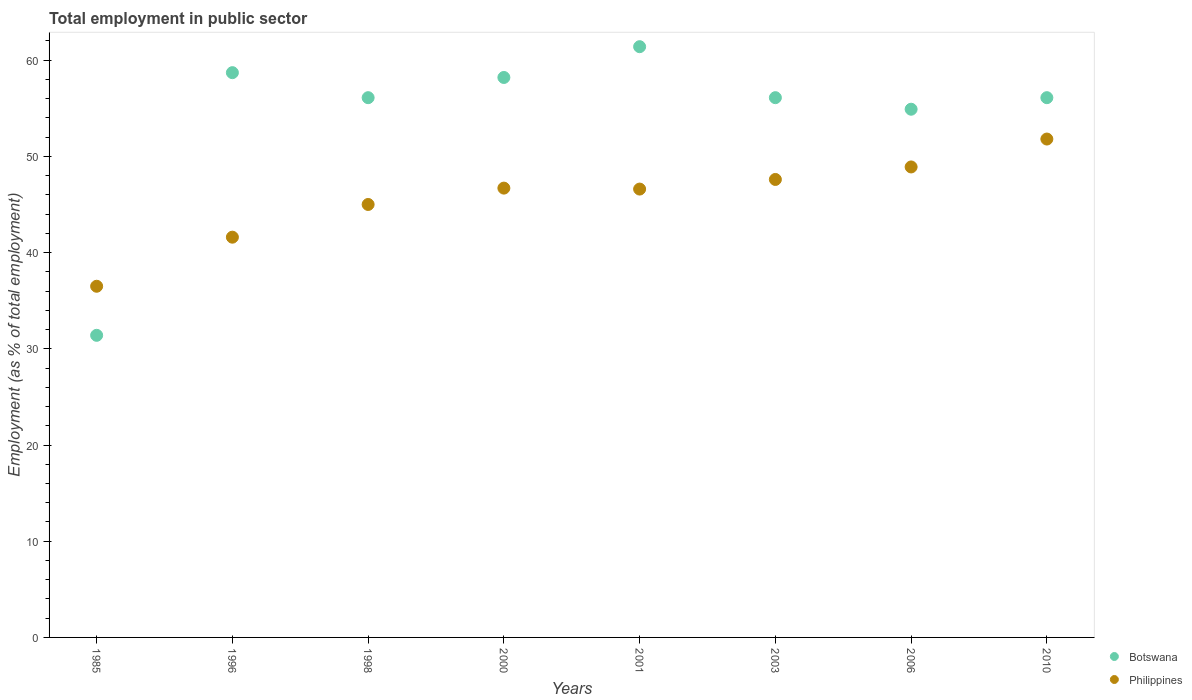Is the number of dotlines equal to the number of legend labels?
Offer a terse response. Yes. What is the employment in public sector in Botswana in 1985?
Keep it short and to the point. 31.4. Across all years, what is the maximum employment in public sector in Botswana?
Offer a very short reply. 61.4. Across all years, what is the minimum employment in public sector in Philippines?
Keep it short and to the point. 36.5. In which year was the employment in public sector in Philippines maximum?
Your answer should be compact. 2010. What is the total employment in public sector in Botswana in the graph?
Offer a very short reply. 432.9. What is the difference between the employment in public sector in Philippines in 2003 and that in 2010?
Keep it short and to the point. -4.2. What is the difference between the employment in public sector in Philippines in 1985 and the employment in public sector in Botswana in 2001?
Your answer should be very brief. -24.9. What is the average employment in public sector in Philippines per year?
Ensure brevity in your answer.  45.59. In the year 1985, what is the difference between the employment in public sector in Philippines and employment in public sector in Botswana?
Offer a terse response. 5.1. In how many years, is the employment in public sector in Botswana greater than 34 %?
Ensure brevity in your answer.  7. What is the ratio of the employment in public sector in Botswana in 1985 to that in 1996?
Offer a terse response. 0.53. Is the employment in public sector in Botswana in 1985 less than that in 2010?
Provide a short and direct response. Yes. Is the difference between the employment in public sector in Philippines in 1998 and 2010 greater than the difference between the employment in public sector in Botswana in 1998 and 2010?
Your response must be concise. No. What is the difference between the highest and the second highest employment in public sector in Philippines?
Your answer should be very brief. 2.9. What is the difference between the highest and the lowest employment in public sector in Botswana?
Provide a short and direct response. 30. Is the sum of the employment in public sector in Botswana in 1996 and 2010 greater than the maximum employment in public sector in Philippines across all years?
Give a very brief answer. Yes. Is the employment in public sector in Philippines strictly greater than the employment in public sector in Botswana over the years?
Provide a succinct answer. No. Is the employment in public sector in Philippines strictly less than the employment in public sector in Botswana over the years?
Make the answer very short. No. Does the graph contain grids?
Give a very brief answer. No. Where does the legend appear in the graph?
Your response must be concise. Bottom right. How many legend labels are there?
Provide a short and direct response. 2. What is the title of the graph?
Ensure brevity in your answer.  Total employment in public sector. What is the label or title of the Y-axis?
Make the answer very short. Employment (as % of total employment). What is the Employment (as % of total employment) in Botswana in 1985?
Your response must be concise. 31.4. What is the Employment (as % of total employment) in Philippines in 1985?
Provide a succinct answer. 36.5. What is the Employment (as % of total employment) of Botswana in 1996?
Your answer should be compact. 58.7. What is the Employment (as % of total employment) in Philippines in 1996?
Provide a succinct answer. 41.6. What is the Employment (as % of total employment) of Botswana in 1998?
Your response must be concise. 56.1. What is the Employment (as % of total employment) of Philippines in 1998?
Offer a terse response. 45. What is the Employment (as % of total employment) of Botswana in 2000?
Your response must be concise. 58.2. What is the Employment (as % of total employment) in Philippines in 2000?
Your answer should be compact. 46.7. What is the Employment (as % of total employment) of Botswana in 2001?
Your answer should be compact. 61.4. What is the Employment (as % of total employment) in Philippines in 2001?
Keep it short and to the point. 46.6. What is the Employment (as % of total employment) of Botswana in 2003?
Provide a succinct answer. 56.1. What is the Employment (as % of total employment) in Philippines in 2003?
Your answer should be compact. 47.6. What is the Employment (as % of total employment) of Botswana in 2006?
Provide a succinct answer. 54.9. What is the Employment (as % of total employment) of Philippines in 2006?
Your response must be concise. 48.9. What is the Employment (as % of total employment) of Botswana in 2010?
Your response must be concise. 56.1. What is the Employment (as % of total employment) in Philippines in 2010?
Keep it short and to the point. 51.8. Across all years, what is the maximum Employment (as % of total employment) of Botswana?
Make the answer very short. 61.4. Across all years, what is the maximum Employment (as % of total employment) in Philippines?
Offer a terse response. 51.8. Across all years, what is the minimum Employment (as % of total employment) of Botswana?
Keep it short and to the point. 31.4. Across all years, what is the minimum Employment (as % of total employment) of Philippines?
Ensure brevity in your answer.  36.5. What is the total Employment (as % of total employment) of Botswana in the graph?
Make the answer very short. 432.9. What is the total Employment (as % of total employment) in Philippines in the graph?
Offer a terse response. 364.7. What is the difference between the Employment (as % of total employment) of Botswana in 1985 and that in 1996?
Ensure brevity in your answer.  -27.3. What is the difference between the Employment (as % of total employment) of Botswana in 1985 and that in 1998?
Offer a very short reply. -24.7. What is the difference between the Employment (as % of total employment) in Philippines in 1985 and that in 1998?
Provide a short and direct response. -8.5. What is the difference between the Employment (as % of total employment) in Botswana in 1985 and that in 2000?
Offer a terse response. -26.8. What is the difference between the Employment (as % of total employment) in Philippines in 1985 and that in 2000?
Your response must be concise. -10.2. What is the difference between the Employment (as % of total employment) of Botswana in 1985 and that in 2003?
Your response must be concise. -24.7. What is the difference between the Employment (as % of total employment) of Philippines in 1985 and that in 2003?
Keep it short and to the point. -11.1. What is the difference between the Employment (as % of total employment) in Botswana in 1985 and that in 2006?
Make the answer very short. -23.5. What is the difference between the Employment (as % of total employment) of Botswana in 1985 and that in 2010?
Keep it short and to the point. -24.7. What is the difference between the Employment (as % of total employment) of Philippines in 1985 and that in 2010?
Provide a short and direct response. -15.3. What is the difference between the Employment (as % of total employment) of Botswana in 1996 and that in 1998?
Your answer should be very brief. 2.6. What is the difference between the Employment (as % of total employment) of Philippines in 1996 and that in 2000?
Your answer should be very brief. -5.1. What is the difference between the Employment (as % of total employment) in Philippines in 1996 and that in 2006?
Offer a terse response. -7.3. What is the difference between the Employment (as % of total employment) of Philippines in 1996 and that in 2010?
Ensure brevity in your answer.  -10.2. What is the difference between the Employment (as % of total employment) in Botswana in 1998 and that in 2000?
Ensure brevity in your answer.  -2.1. What is the difference between the Employment (as % of total employment) in Philippines in 1998 and that in 2000?
Your response must be concise. -1.7. What is the difference between the Employment (as % of total employment) in Philippines in 1998 and that in 2001?
Provide a short and direct response. -1.6. What is the difference between the Employment (as % of total employment) of Philippines in 1998 and that in 2003?
Your response must be concise. -2.6. What is the difference between the Employment (as % of total employment) in Botswana in 1998 and that in 2006?
Provide a succinct answer. 1.2. What is the difference between the Employment (as % of total employment) of Philippines in 1998 and that in 2006?
Your response must be concise. -3.9. What is the difference between the Employment (as % of total employment) in Philippines in 1998 and that in 2010?
Ensure brevity in your answer.  -6.8. What is the difference between the Employment (as % of total employment) of Botswana in 2000 and that in 2001?
Provide a succinct answer. -3.2. What is the difference between the Employment (as % of total employment) in Philippines in 2000 and that in 2001?
Keep it short and to the point. 0.1. What is the difference between the Employment (as % of total employment) of Botswana in 2000 and that in 2003?
Your answer should be very brief. 2.1. What is the difference between the Employment (as % of total employment) of Botswana in 2000 and that in 2010?
Offer a very short reply. 2.1. What is the difference between the Employment (as % of total employment) in Philippines in 2000 and that in 2010?
Give a very brief answer. -5.1. What is the difference between the Employment (as % of total employment) in Botswana in 2001 and that in 2003?
Provide a succinct answer. 5.3. What is the difference between the Employment (as % of total employment) of Philippines in 2001 and that in 2006?
Offer a terse response. -2.3. What is the difference between the Employment (as % of total employment) of Philippines in 2003 and that in 2006?
Your answer should be very brief. -1.3. What is the difference between the Employment (as % of total employment) of Botswana in 2006 and that in 2010?
Offer a very short reply. -1.2. What is the difference between the Employment (as % of total employment) in Botswana in 1985 and the Employment (as % of total employment) in Philippines in 2000?
Ensure brevity in your answer.  -15.3. What is the difference between the Employment (as % of total employment) of Botswana in 1985 and the Employment (as % of total employment) of Philippines in 2001?
Your answer should be compact. -15.2. What is the difference between the Employment (as % of total employment) in Botswana in 1985 and the Employment (as % of total employment) in Philippines in 2003?
Offer a very short reply. -16.2. What is the difference between the Employment (as % of total employment) of Botswana in 1985 and the Employment (as % of total employment) of Philippines in 2006?
Offer a terse response. -17.5. What is the difference between the Employment (as % of total employment) of Botswana in 1985 and the Employment (as % of total employment) of Philippines in 2010?
Make the answer very short. -20.4. What is the difference between the Employment (as % of total employment) in Botswana in 1996 and the Employment (as % of total employment) in Philippines in 2000?
Your answer should be compact. 12. What is the difference between the Employment (as % of total employment) in Botswana in 1996 and the Employment (as % of total employment) in Philippines in 2006?
Provide a short and direct response. 9.8. What is the difference between the Employment (as % of total employment) in Botswana in 1998 and the Employment (as % of total employment) in Philippines in 2001?
Offer a very short reply. 9.5. What is the difference between the Employment (as % of total employment) in Botswana in 1998 and the Employment (as % of total employment) in Philippines in 2003?
Make the answer very short. 8.5. What is the difference between the Employment (as % of total employment) in Botswana in 1998 and the Employment (as % of total employment) in Philippines in 2006?
Offer a terse response. 7.2. What is the difference between the Employment (as % of total employment) in Botswana in 2000 and the Employment (as % of total employment) in Philippines in 2006?
Offer a terse response. 9.3. What is the difference between the Employment (as % of total employment) in Botswana in 2000 and the Employment (as % of total employment) in Philippines in 2010?
Make the answer very short. 6.4. What is the difference between the Employment (as % of total employment) in Botswana in 2001 and the Employment (as % of total employment) in Philippines in 2006?
Make the answer very short. 12.5. What is the difference between the Employment (as % of total employment) in Botswana in 2001 and the Employment (as % of total employment) in Philippines in 2010?
Offer a very short reply. 9.6. What is the difference between the Employment (as % of total employment) in Botswana in 2006 and the Employment (as % of total employment) in Philippines in 2010?
Keep it short and to the point. 3.1. What is the average Employment (as % of total employment) of Botswana per year?
Your answer should be compact. 54.11. What is the average Employment (as % of total employment) in Philippines per year?
Offer a terse response. 45.59. In the year 1996, what is the difference between the Employment (as % of total employment) in Botswana and Employment (as % of total employment) in Philippines?
Your answer should be compact. 17.1. In the year 1998, what is the difference between the Employment (as % of total employment) of Botswana and Employment (as % of total employment) of Philippines?
Keep it short and to the point. 11.1. In the year 2006, what is the difference between the Employment (as % of total employment) in Botswana and Employment (as % of total employment) in Philippines?
Your response must be concise. 6. In the year 2010, what is the difference between the Employment (as % of total employment) in Botswana and Employment (as % of total employment) in Philippines?
Ensure brevity in your answer.  4.3. What is the ratio of the Employment (as % of total employment) of Botswana in 1985 to that in 1996?
Ensure brevity in your answer.  0.53. What is the ratio of the Employment (as % of total employment) in Philippines in 1985 to that in 1996?
Make the answer very short. 0.88. What is the ratio of the Employment (as % of total employment) in Botswana in 1985 to that in 1998?
Offer a terse response. 0.56. What is the ratio of the Employment (as % of total employment) of Philippines in 1985 to that in 1998?
Offer a terse response. 0.81. What is the ratio of the Employment (as % of total employment) of Botswana in 1985 to that in 2000?
Your response must be concise. 0.54. What is the ratio of the Employment (as % of total employment) of Philippines in 1985 to that in 2000?
Keep it short and to the point. 0.78. What is the ratio of the Employment (as % of total employment) in Botswana in 1985 to that in 2001?
Your answer should be very brief. 0.51. What is the ratio of the Employment (as % of total employment) in Philippines in 1985 to that in 2001?
Offer a very short reply. 0.78. What is the ratio of the Employment (as % of total employment) of Botswana in 1985 to that in 2003?
Your answer should be very brief. 0.56. What is the ratio of the Employment (as % of total employment) of Philippines in 1985 to that in 2003?
Ensure brevity in your answer.  0.77. What is the ratio of the Employment (as % of total employment) of Botswana in 1985 to that in 2006?
Offer a very short reply. 0.57. What is the ratio of the Employment (as % of total employment) of Philippines in 1985 to that in 2006?
Make the answer very short. 0.75. What is the ratio of the Employment (as % of total employment) in Botswana in 1985 to that in 2010?
Offer a very short reply. 0.56. What is the ratio of the Employment (as % of total employment) in Philippines in 1985 to that in 2010?
Keep it short and to the point. 0.7. What is the ratio of the Employment (as % of total employment) in Botswana in 1996 to that in 1998?
Give a very brief answer. 1.05. What is the ratio of the Employment (as % of total employment) in Philippines in 1996 to that in 1998?
Your answer should be compact. 0.92. What is the ratio of the Employment (as % of total employment) of Botswana in 1996 to that in 2000?
Give a very brief answer. 1.01. What is the ratio of the Employment (as % of total employment) of Philippines in 1996 to that in 2000?
Provide a succinct answer. 0.89. What is the ratio of the Employment (as % of total employment) in Botswana in 1996 to that in 2001?
Your answer should be very brief. 0.96. What is the ratio of the Employment (as % of total employment) of Philippines in 1996 to that in 2001?
Your answer should be compact. 0.89. What is the ratio of the Employment (as % of total employment) of Botswana in 1996 to that in 2003?
Provide a short and direct response. 1.05. What is the ratio of the Employment (as % of total employment) in Philippines in 1996 to that in 2003?
Provide a succinct answer. 0.87. What is the ratio of the Employment (as % of total employment) of Botswana in 1996 to that in 2006?
Make the answer very short. 1.07. What is the ratio of the Employment (as % of total employment) of Philippines in 1996 to that in 2006?
Offer a very short reply. 0.85. What is the ratio of the Employment (as % of total employment) in Botswana in 1996 to that in 2010?
Provide a succinct answer. 1.05. What is the ratio of the Employment (as % of total employment) in Philippines in 1996 to that in 2010?
Make the answer very short. 0.8. What is the ratio of the Employment (as % of total employment) in Botswana in 1998 to that in 2000?
Make the answer very short. 0.96. What is the ratio of the Employment (as % of total employment) of Philippines in 1998 to that in 2000?
Your answer should be very brief. 0.96. What is the ratio of the Employment (as % of total employment) in Botswana in 1998 to that in 2001?
Your response must be concise. 0.91. What is the ratio of the Employment (as % of total employment) of Philippines in 1998 to that in 2001?
Your answer should be compact. 0.97. What is the ratio of the Employment (as % of total employment) of Philippines in 1998 to that in 2003?
Make the answer very short. 0.95. What is the ratio of the Employment (as % of total employment) of Botswana in 1998 to that in 2006?
Keep it short and to the point. 1.02. What is the ratio of the Employment (as % of total employment) in Philippines in 1998 to that in 2006?
Make the answer very short. 0.92. What is the ratio of the Employment (as % of total employment) of Botswana in 1998 to that in 2010?
Offer a terse response. 1. What is the ratio of the Employment (as % of total employment) in Philippines in 1998 to that in 2010?
Keep it short and to the point. 0.87. What is the ratio of the Employment (as % of total employment) of Botswana in 2000 to that in 2001?
Provide a short and direct response. 0.95. What is the ratio of the Employment (as % of total employment) in Philippines in 2000 to that in 2001?
Provide a succinct answer. 1. What is the ratio of the Employment (as % of total employment) in Botswana in 2000 to that in 2003?
Offer a terse response. 1.04. What is the ratio of the Employment (as % of total employment) in Philippines in 2000 to that in 2003?
Provide a succinct answer. 0.98. What is the ratio of the Employment (as % of total employment) in Botswana in 2000 to that in 2006?
Provide a short and direct response. 1.06. What is the ratio of the Employment (as % of total employment) in Philippines in 2000 to that in 2006?
Provide a short and direct response. 0.95. What is the ratio of the Employment (as % of total employment) of Botswana in 2000 to that in 2010?
Your response must be concise. 1.04. What is the ratio of the Employment (as % of total employment) of Philippines in 2000 to that in 2010?
Make the answer very short. 0.9. What is the ratio of the Employment (as % of total employment) of Botswana in 2001 to that in 2003?
Your answer should be compact. 1.09. What is the ratio of the Employment (as % of total employment) of Philippines in 2001 to that in 2003?
Provide a succinct answer. 0.98. What is the ratio of the Employment (as % of total employment) of Botswana in 2001 to that in 2006?
Provide a short and direct response. 1.12. What is the ratio of the Employment (as % of total employment) of Philippines in 2001 to that in 2006?
Give a very brief answer. 0.95. What is the ratio of the Employment (as % of total employment) in Botswana in 2001 to that in 2010?
Make the answer very short. 1.09. What is the ratio of the Employment (as % of total employment) in Philippines in 2001 to that in 2010?
Offer a terse response. 0.9. What is the ratio of the Employment (as % of total employment) of Botswana in 2003 to that in 2006?
Make the answer very short. 1.02. What is the ratio of the Employment (as % of total employment) in Philippines in 2003 to that in 2006?
Give a very brief answer. 0.97. What is the ratio of the Employment (as % of total employment) of Philippines in 2003 to that in 2010?
Provide a short and direct response. 0.92. What is the ratio of the Employment (as % of total employment) of Botswana in 2006 to that in 2010?
Ensure brevity in your answer.  0.98. What is the ratio of the Employment (as % of total employment) of Philippines in 2006 to that in 2010?
Offer a very short reply. 0.94. What is the difference between the highest and the lowest Employment (as % of total employment) of Botswana?
Keep it short and to the point. 30. What is the difference between the highest and the lowest Employment (as % of total employment) in Philippines?
Give a very brief answer. 15.3. 